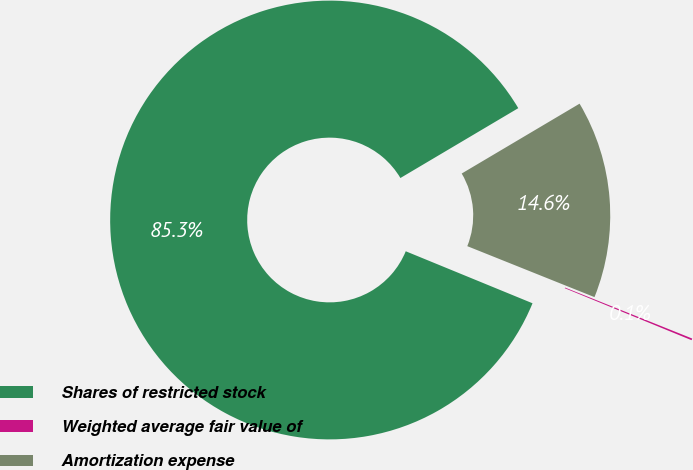<chart> <loc_0><loc_0><loc_500><loc_500><pie_chart><fcel>Shares of restricted stock<fcel>Weighted average fair value of<fcel>Amortization expense<nl><fcel>85.29%<fcel>0.13%<fcel>14.58%<nl></chart> 